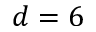Convert formula to latex. <formula><loc_0><loc_0><loc_500><loc_500>d = 6</formula> 